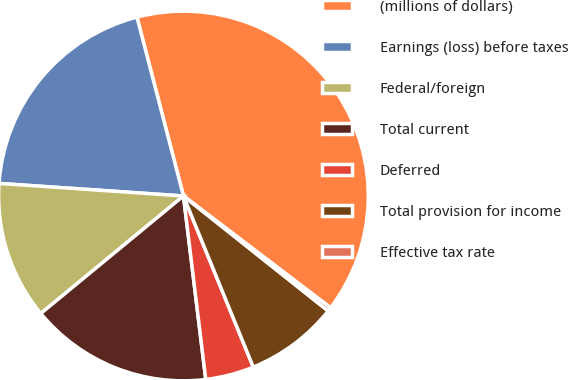Convert chart to OTSL. <chart><loc_0><loc_0><loc_500><loc_500><pie_chart><fcel>(millions of dollars)<fcel>Earnings (loss) before taxes<fcel>Federal/foreign<fcel>Total current<fcel>Deferred<fcel>Total provision for income<fcel>Effective tax rate<nl><fcel>39.4%<fcel>19.87%<fcel>12.05%<fcel>15.96%<fcel>4.24%<fcel>8.15%<fcel>0.34%<nl></chart> 